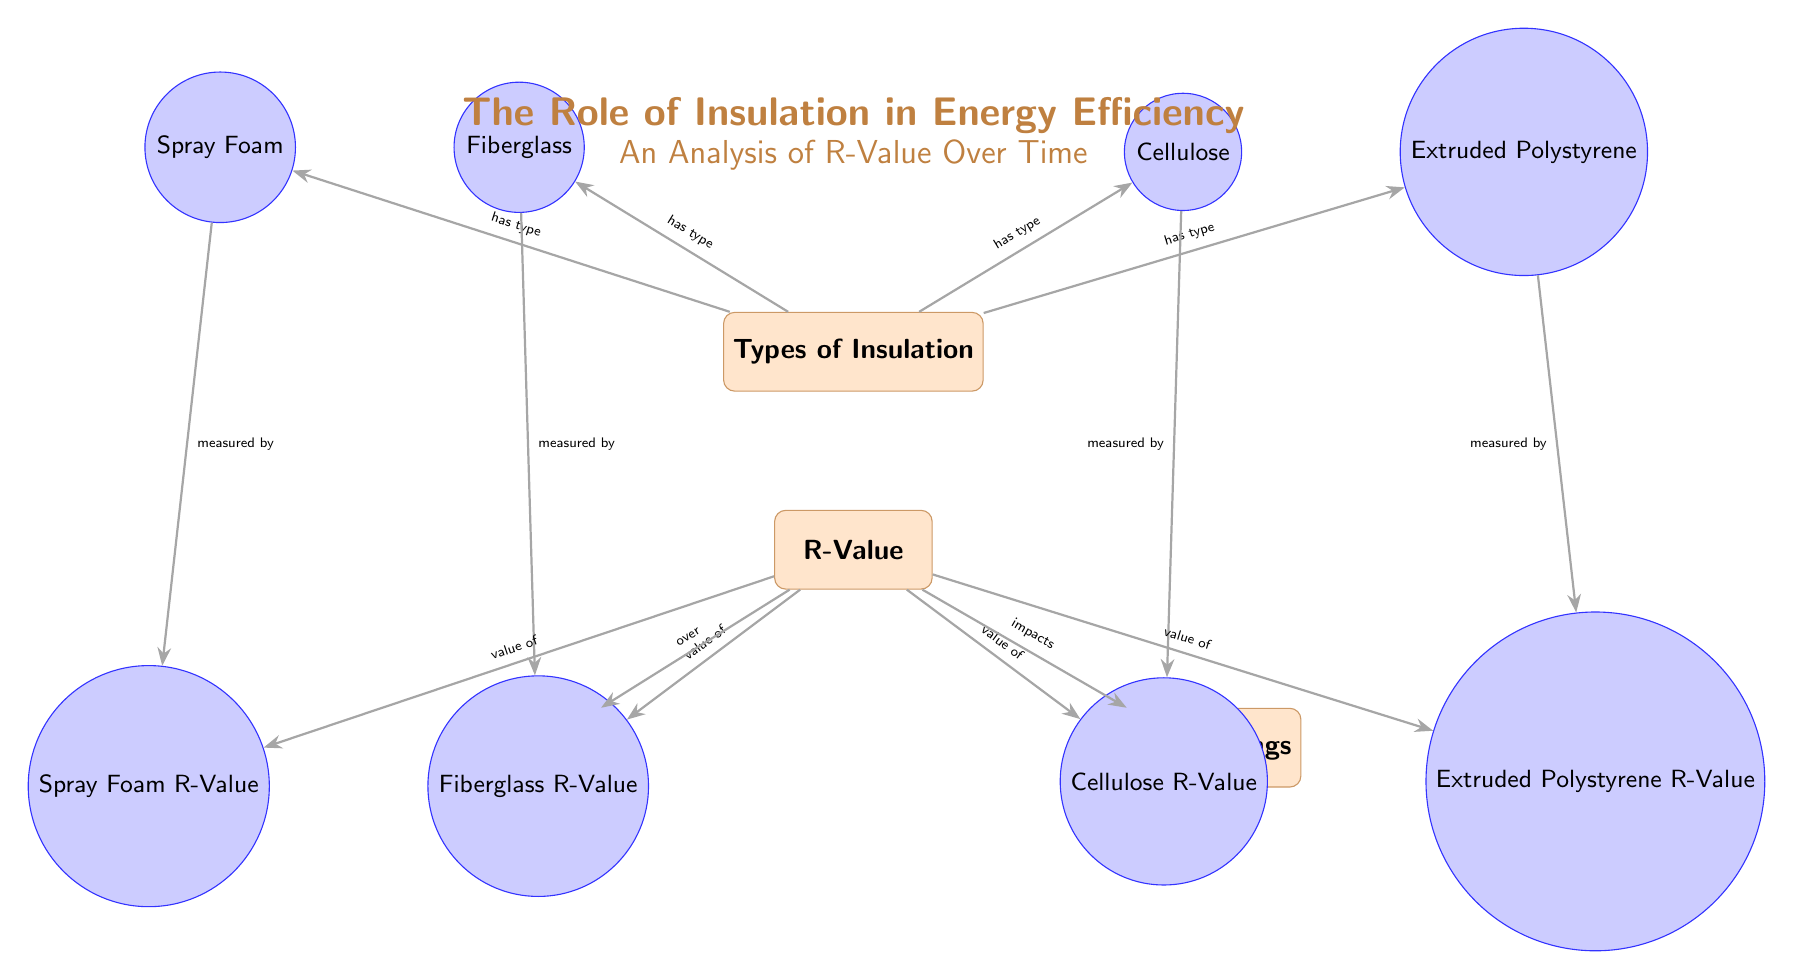What are the types of insulation presented in the diagram? The diagram lists four types of insulation: Fiberglass, Spray Foam, Cellulose, and Extruded Polystyrene. These are directly connected to the "Types of Insulation" node, clearly labeled in the diagram.
Answer: Fiberglass, Spray Foam, Cellulose, Extruded Polystyrene How many insulation types are shown in the diagram? There are four insulation types displayed in the diagram, as identified by the four circle nodes connected to "Types of Insulation."
Answer: 4 What does the R-Value directly impact according to the diagram? The R-Value is linked to "Energy Savings," indicating that it has an impact on energy savings. This connection shows that the R-Value is important for understanding how energy efficiency is affected.
Answer: Energy Savings What does the node labeled "R-Value" lead to in the diagram? The "R-Value" node connects to several other nodes: "Years" and "Energy Savings." This means the R-Value is associated both with the duration over which it is measured and the energy savings implications.
Answer: Years, Energy Savings What is the relationship between "Types of Insulation" and "R-Value"? The diagram indicates that the "Types of Insulation" have specific R-Values that are measured by their corresponding sub-nodes. Each type of insulation has its own defined R-Value. This shows a direct link between the type and its measured effectiveness.
Answer: Has type What are the R-Values associated with Spray Foam? According to the diagram, there is a specific node for "Spray Foam R-Value" that signifies the R-Value corresponding to Spray Foam insulation; it is directly connected to the "R-Value" node.
Answer: Spray Foam R-Value How are the years related to the R-Value in the diagram? The diagram shows a direct arrow from the "R-Value" node to "Years," indicating that R-Value is assessed or measured over a period of years, suggesting a time-dependent evaluation of insulation effectiveness.
Answer: Over Which insulation type does not have its R-Value illustrated in the diagram? All insulation types presented in the diagram are linked to their respective R-Values, and since the question implies one type may be missing, the answer indicates that none are excluded. Thus, all types of insulation do have their corresponding R-Values displayed.
Answer: None 